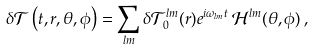Convert formula to latex. <formula><loc_0><loc_0><loc_500><loc_500>\delta \mathcal { T } \left ( t , r , \theta , \phi \right ) = \sum _ { l m } \delta \mathcal { T } ^ { l m } _ { 0 } ( r ) e ^ { i \omega _ { l m } t } \, \mathcal { H } ^ { l m } ( \theta , \phi ) \, ,</formula> 